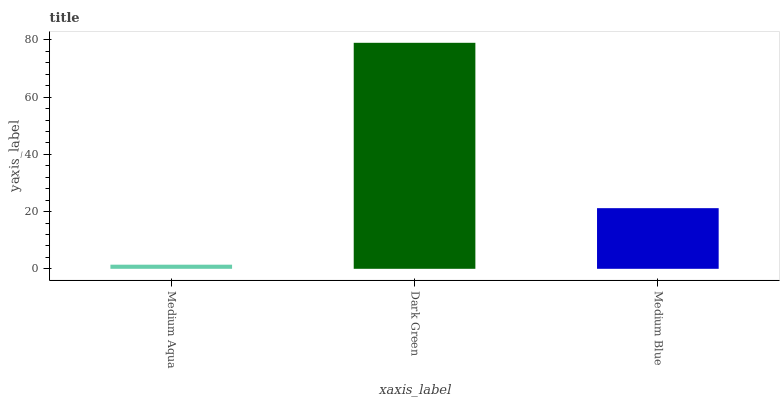Is Medium Aqua the minimum?
Answer yes or no. Yes. Is Dark Green the maximum?
Answer yes or no. Yes. Is Medium Blue the minimum?
Answer yes or no. No. Is Medium Blue the maximum?
Answer yes or no. No. Is Dark Green greater than Medium Blue?
Answer yes or no. Yes. Is Medium Blue less than Dark Green?
Answer yes or no. Yes. Is Medium Blue greater than Dark Green?
Answer yes or no. No. Is Dark Green less than Medium Blue?
Answer yes or no. No. Is Medium Blue the high median?
Answer yes or no. Yes. Is Medium Blue the low median?
Answer yes or no. Yes. Is Medium Aqua the high median?
Answer yes or no. No. Is Medium Aqua the low median?
Answer yes or no. No. 